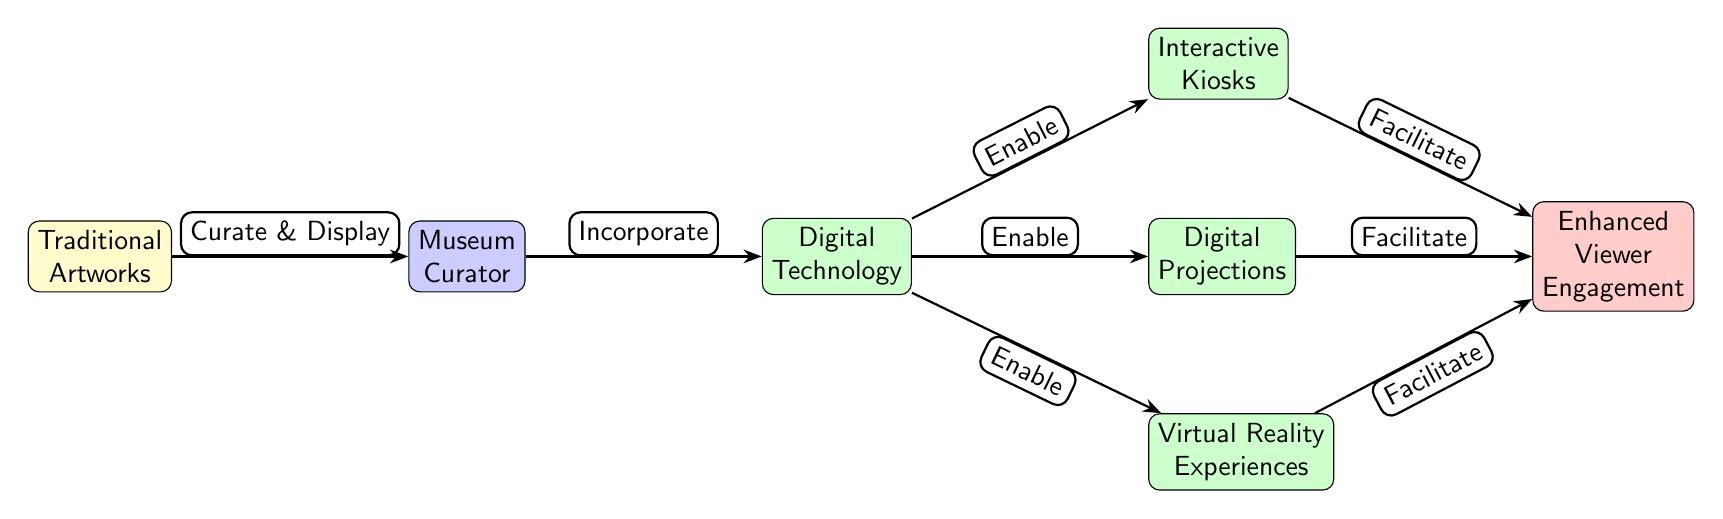What is the first node in the diagram? The first node in the diagram is labeled 'Traditional Artworks', which is positioned at the leftmost part of the diagram.
Answer: Traditional Artworks What type of relationship exists between 'Curator' and 'Digital Technology'? The diagram indicates a relationship where the Curator 'Incorporates' Digital Technology since there's an edge labeled 'Incorporate' pointing from Curator to Digital Technology.
Answer: Incorporate How many technology nodes are present in the diagram? There are three technology nodes: 'Interactive Kiosks', 'Digital Projections', and 'Virtual Reality Experiences'. Counting these nodes gives a total of three.
Answer: 3 What facilitates 'Enhanced Viewer Engagement'? The 'Enhanced Viewer Engagement' is facilitated by three nodes: 'Interactive Kiosks', 'Digital Projections', and 'Virtual Reality Experiences', which all have edges leading to it indicating their role in facilitation.
Answer: Interactive Kiosks, Digital Projections, Virtual Reality Experiences Which node is directly connected to 'Traditional Artworks'? The node directly connected to 'Traditional Artworks' is 'Museum Curator', which has an edge labeled 'Curate & Display' leading to it.
Answer: Museum Curator What is the flow direction from 'Digital Technology' to 'Enhanced Viewer Engagement'? The flow direction is that Digital Technology 'Enables' three technology nodes, which in turn 'Facilitate' Enhanced Viewer Engagement. This shows a clear path of influence from Digital Technology to Viewer Engagement.
Answer: Enables What is the significance of the 'Curate & Display' edge? The 'Curate & Display' edge indicates that the Museum Curator is responsible for the curation and display of the Traditional Artworks, suggesting that this is a foundational step in the exhibition process.
Answer: Curate & Display What is a primary role of 'Digital Technology' in this diagram? A primary role of 'Digital Technology' in this diagram is to 'Enable' various forms of technology such as Interactive Kiosks, Digital Projections, and Virtual Reality Experiences to enhance viewer engagement.
Answer: Enable 